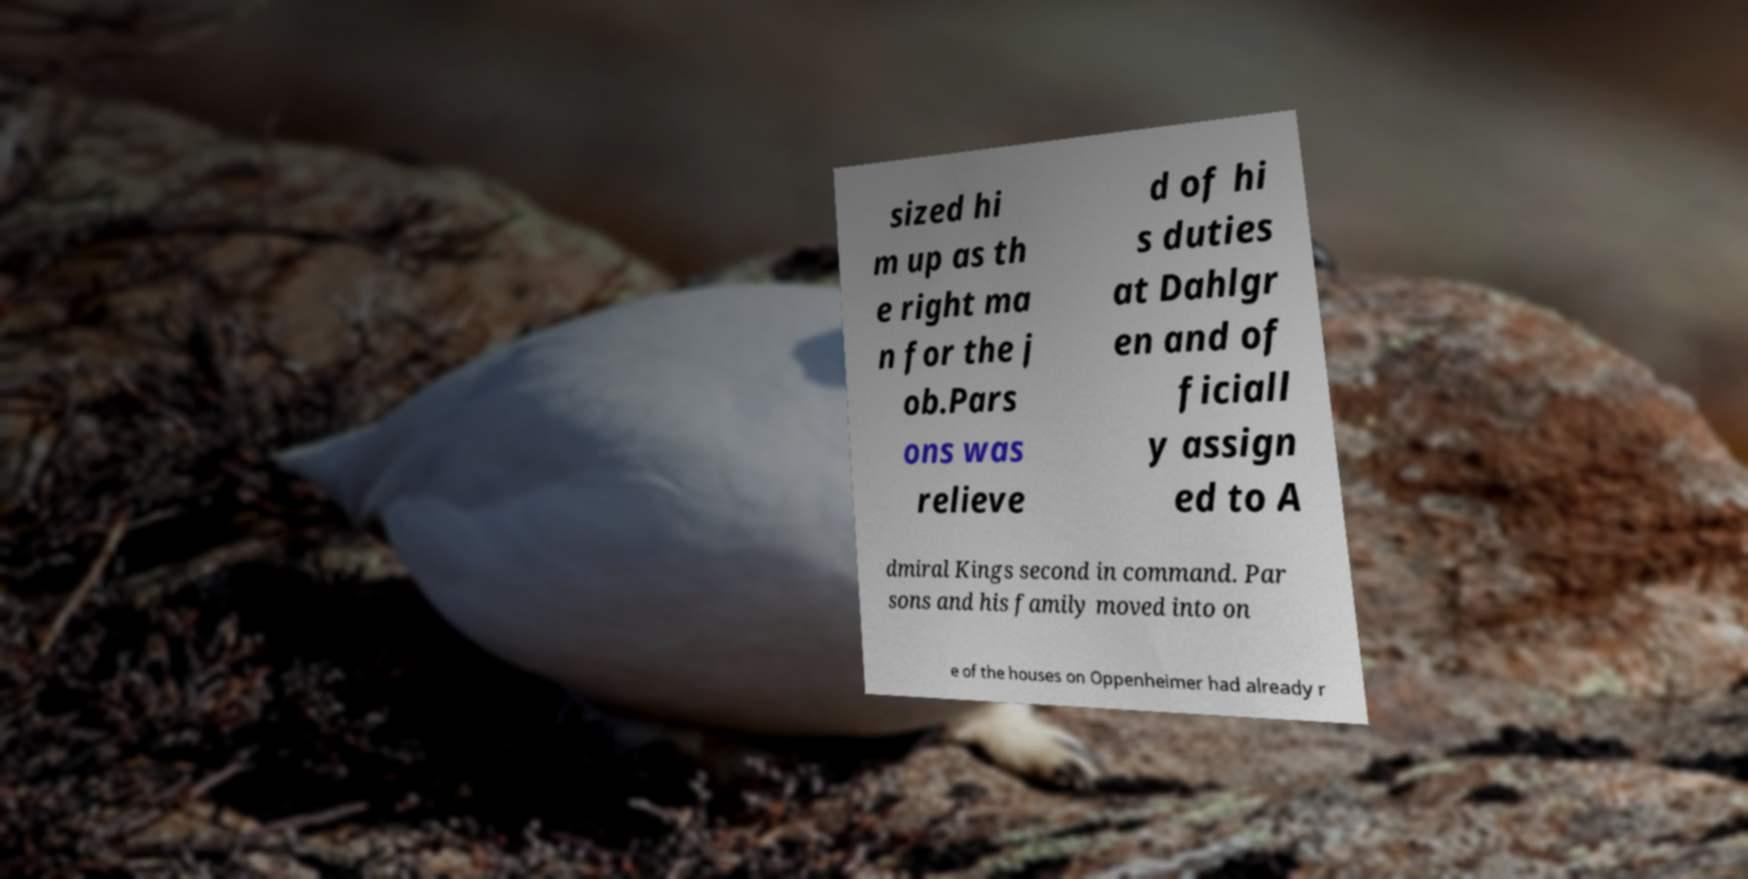What messages or text are displayed in this image? I need them in a readable, typed format. sized hi m up as th e right ma n for the j ob.Pars ons was relieve d of hi s duties at Dahlgr en and of ficiall y assign ed to A dmiral Kings second in command. Par sons and his family moved into on e of the houses on Oppenheimer had already r 